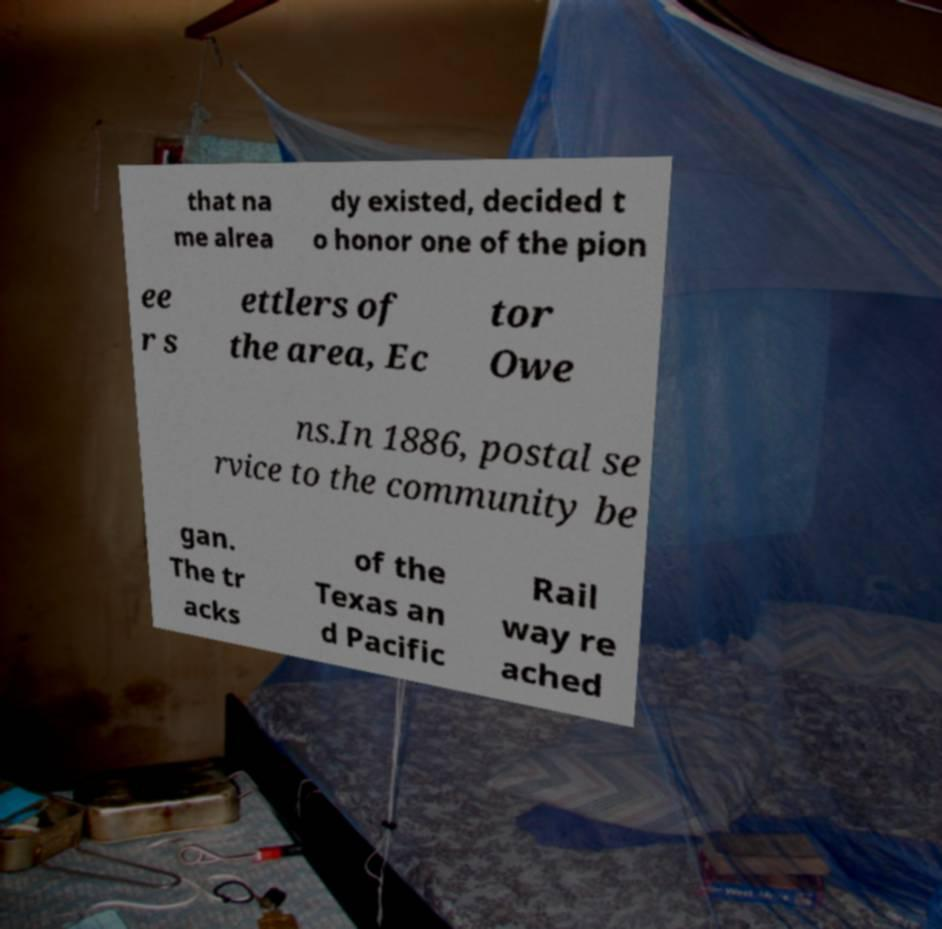Could you assist in decoding the text presented in this image and type it out clearly? that na me alrea dy existed, decided t o honor one of the pion ee r s ettlers of the area, Ec tor Owe ns.In 1886, postal se rvice to the community be gan. The tr acks of the Texas an d Pacific Rail way re ached 